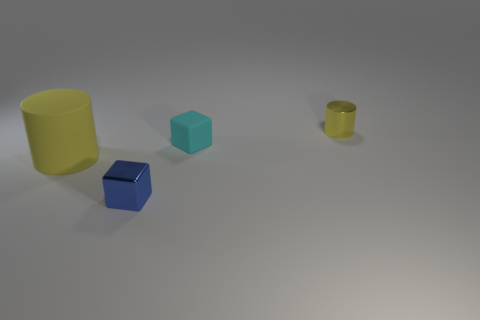Subtract all cyan blocks. How many blocks are left? 1 Add 2 tiny cyan matte balls. How many objects exist? 6 Add 3 metallic objects. How many metallic objects are left? 5 Add 1 small blue matte blocks. How many small blue matte blocks exist? 1 Subtract 0 gray balls. How many objects are left? 4 Subtract all brown cylinders. Subtract all brown spheres. How many cylinders are left? 2 Subtract all cyan cylinders. How many cyan cubes are left? 1 Subtract all blue shiny blocks. Subtract all tiny metal things. How many objects are left? 1 